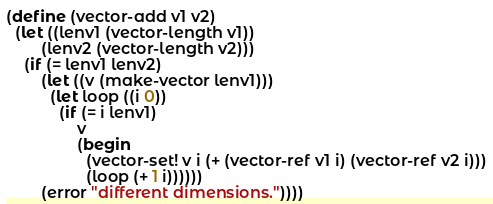Convert code to text. <code><loc_0><loc_0><loc_500><loc_500><_Scheme_>(define (vector-add v1 v2)
  (let ((lenv1 (vector-length v1))
        (lenv2 (vector-length v2)))
    (if (= lenv1 lenv2)
        (let ((v (make-vector lenv1)))
          (let loop ((i 0))
            (if (= i lenv1)
                v
                (begin
                  (vector-set! v i (+ (vector-ref v1 i) (vector-ref v2 i)))
                  (loop (+ 1 i))))))
        (error "different dimensions."))))
</code> 